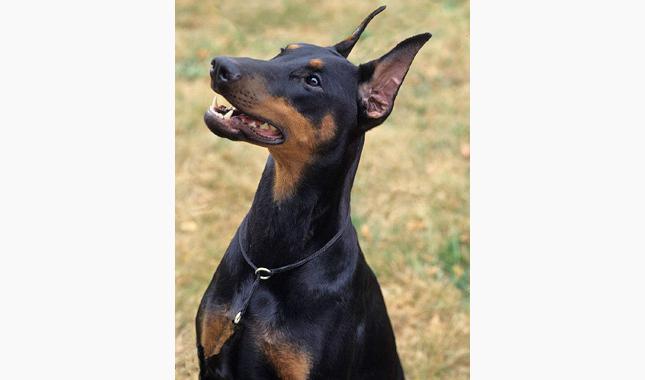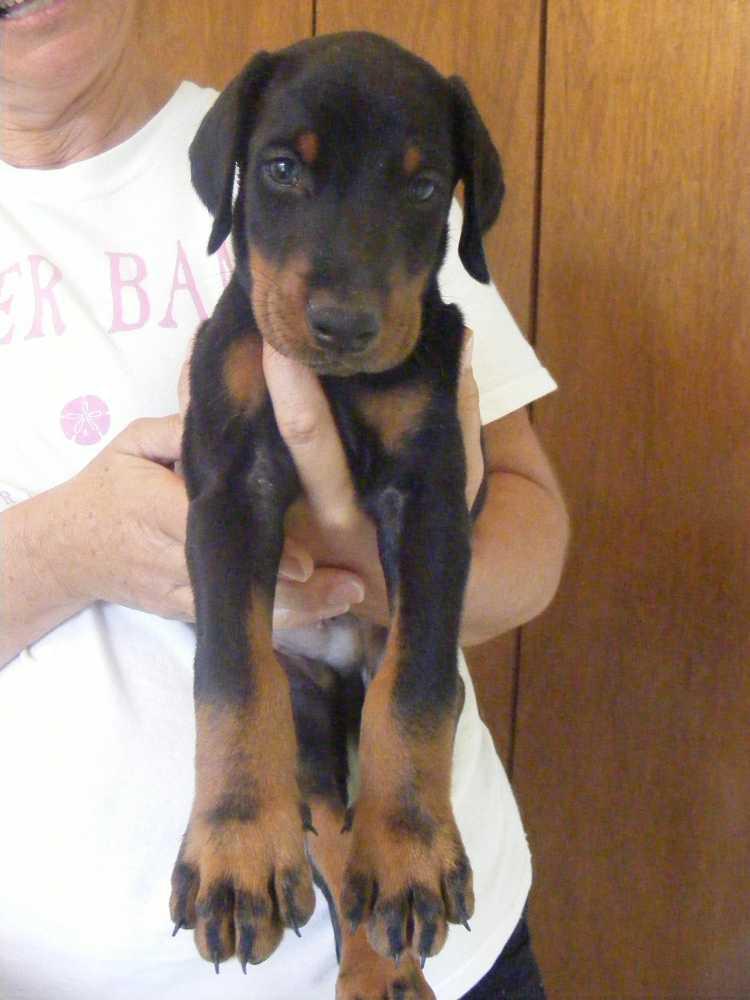The first image is the image on the left, the second image is the image on the right. For the images shown, is this caption "There is a young puppy in one image." true? Answer yes or no. Yes. The first image is the image on the left, the second image is the image on the right. For the images shown, is this caption "One of the dogs has floppy ears." true? Answer yes or no. Yes. 